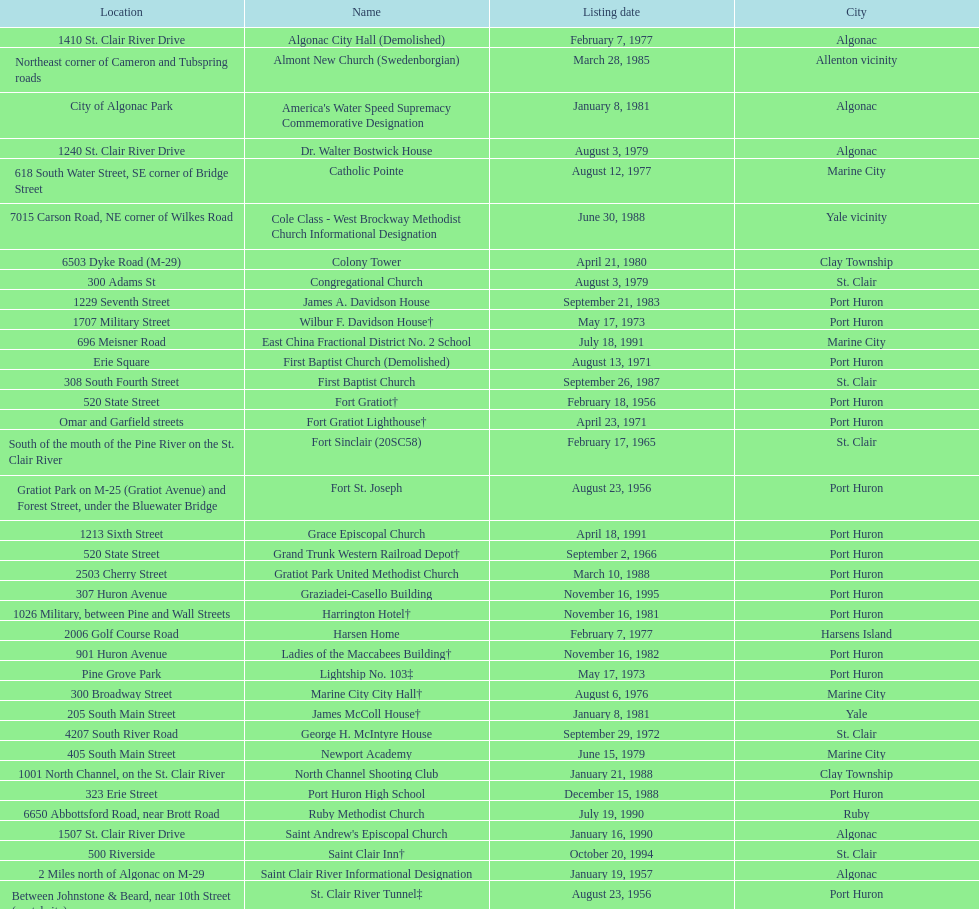Which city is home to the greatest number of historic sites, existing or demolished? Port Huron. 